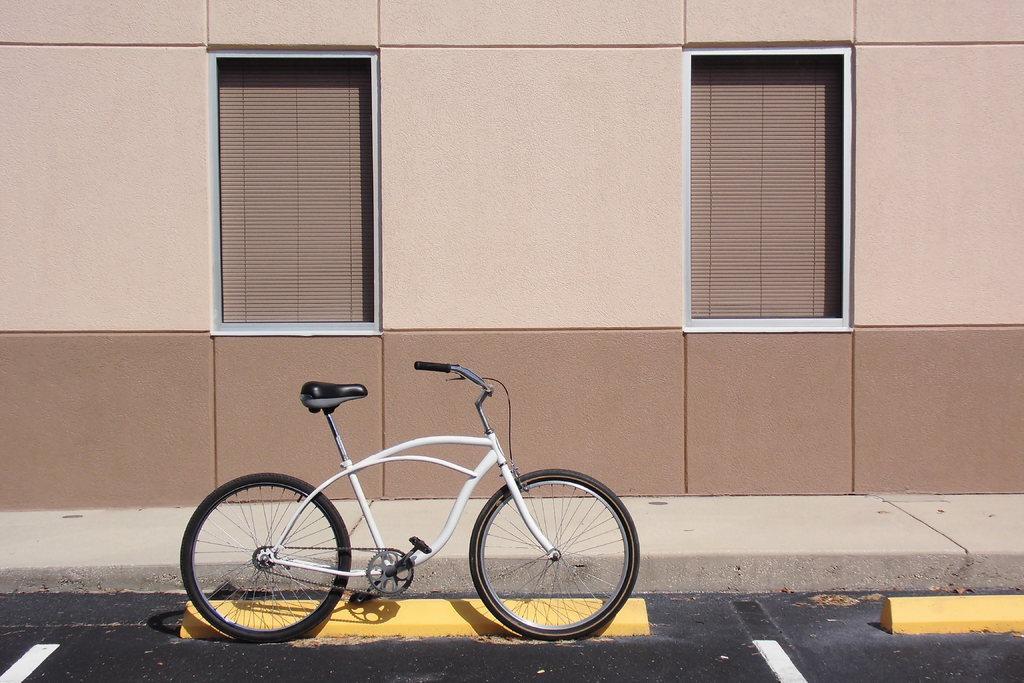Please provide a concise description of this image. In the picture I can see a bicycle which is in white color and there is a yellow color object beside it and there is a building which has two windows on it. 